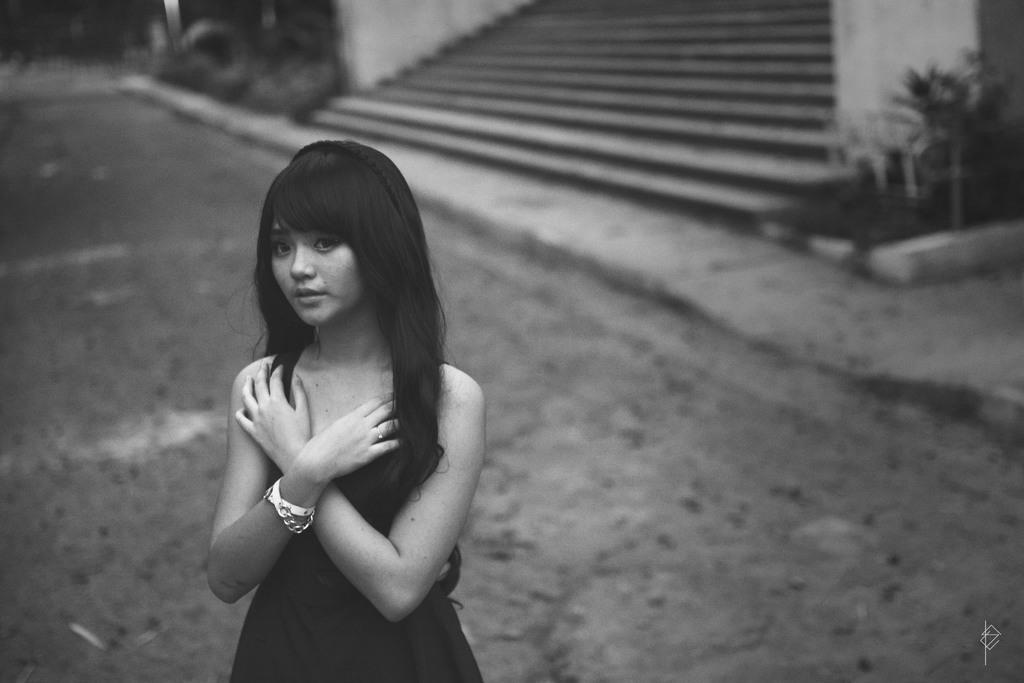Can you describe this image briefly? This is a black and white image. In this image we can see a lady. In the background there are steps and plants. And it is blurry in the background. 